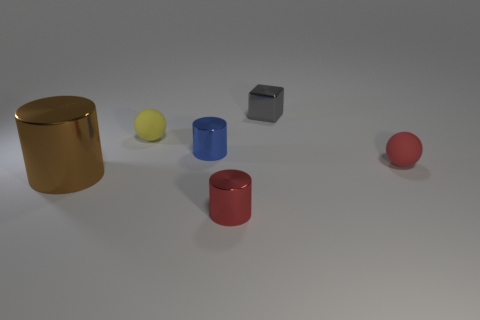Subtract all red cylinders. How many cylinders are left? 2 Subtract all red cylinders. How many cylinders are left? 2 Add 3 big brown metal objects. How many objects exist? 9 Subtract 2 cylinders. How many cylinders are left? 1 Subtract all red cubes. How many brown cylinders are left? 1 Subtract all purple metallic objects. Subtract all matte things. How many objects are left? 4 Add 5 metal things. How many metal things are left? 9 Add 5 green cylinders. How many green cylinders exist? 5 Subtract 0 cyan spheres. How many objects are left? 6 Subtract all balls. How many objects are left? 4 